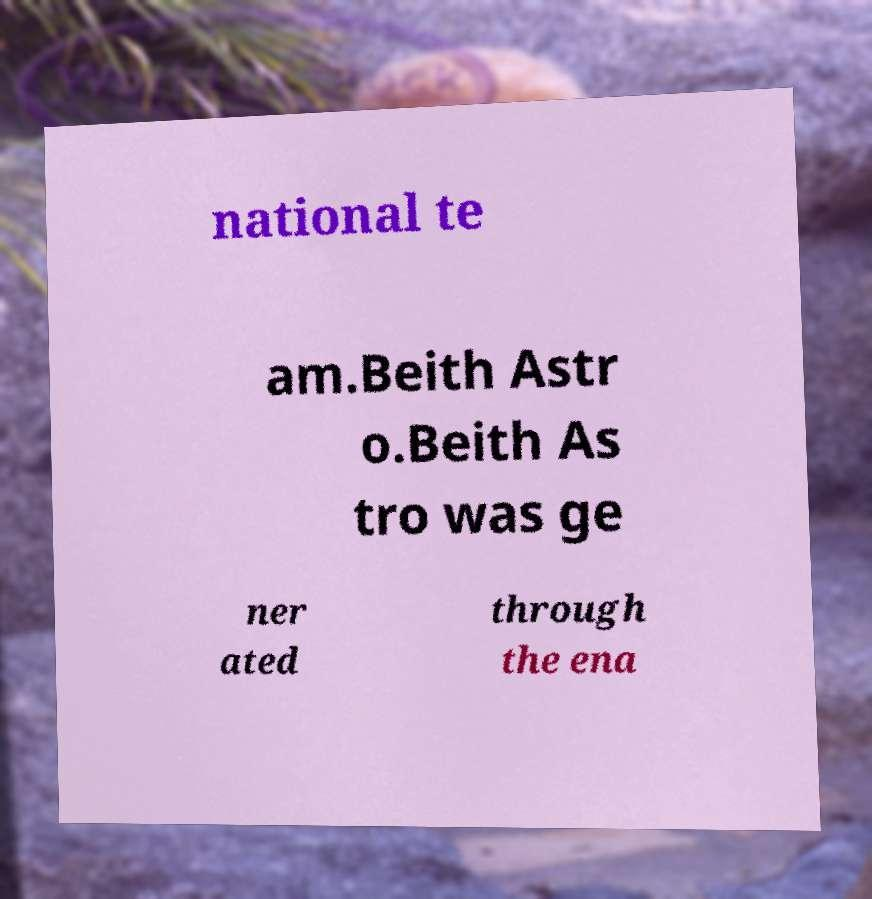Can you read and provide the text displayed in the image?This photo seems to have some interesting text. Can you extract and type it out for me? national te am.Beith Astr o.Beith As tro was ge ner ated through the ena 